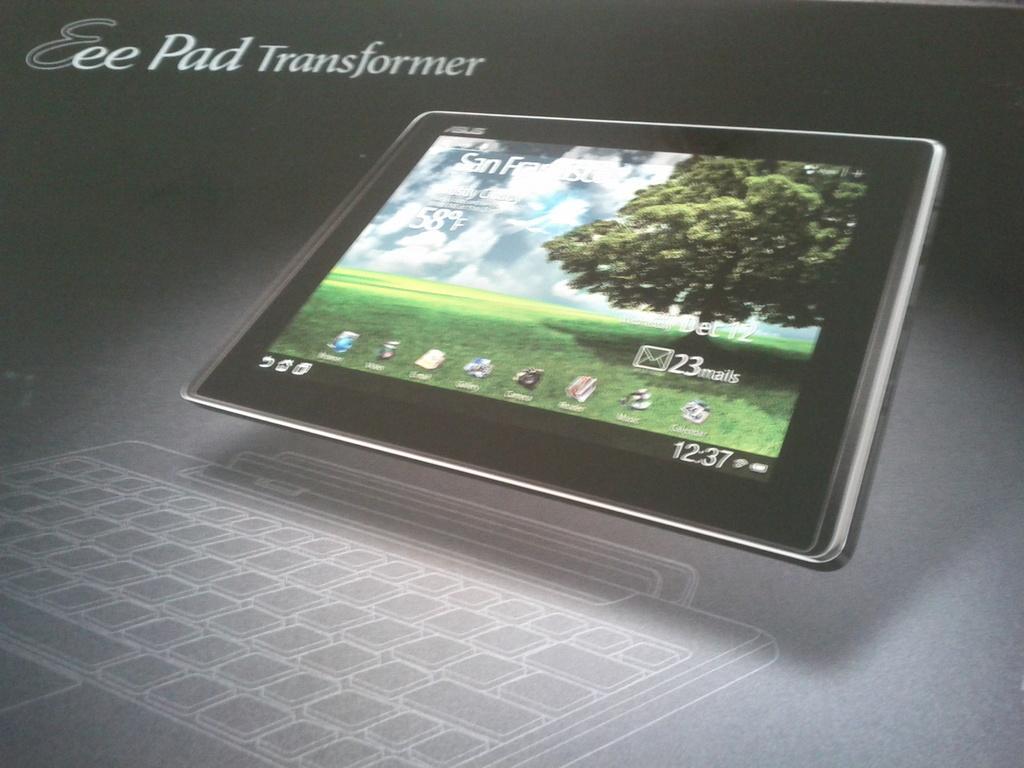In one or two sentences, can you explain what this image depicts? This image is an animation. In the center we can see a tablet. At the bottom there is a keypad and we can see text. 